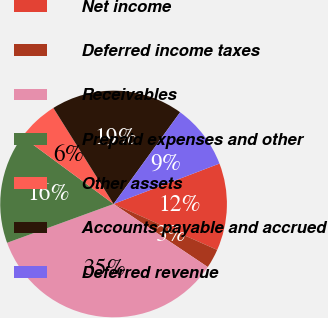Convert chart to OTSL. <chart><loc_0><loc_0><loc_500><loc_500><pie_chart><fcel>Net income<fcel>Deferred income taxes<fcel>Receivables<fcel>Prepaid expenses and other<fcel>Other assets<fcel>Accounts payable and accrued<fcel>Deferred revenue<nl><fcel>12.44%<fcel>2.75%<fcel>35.05%<fcel>15.67%<fcel>5.98%<fcel>18.9%<fcel>9.21%<nl></chart> 